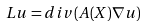Convert formula to latex. <formula><loc_0><loc_0><loc_500><loc_500>L u = d i v ( A ( X ) \nabla u )</formula> 